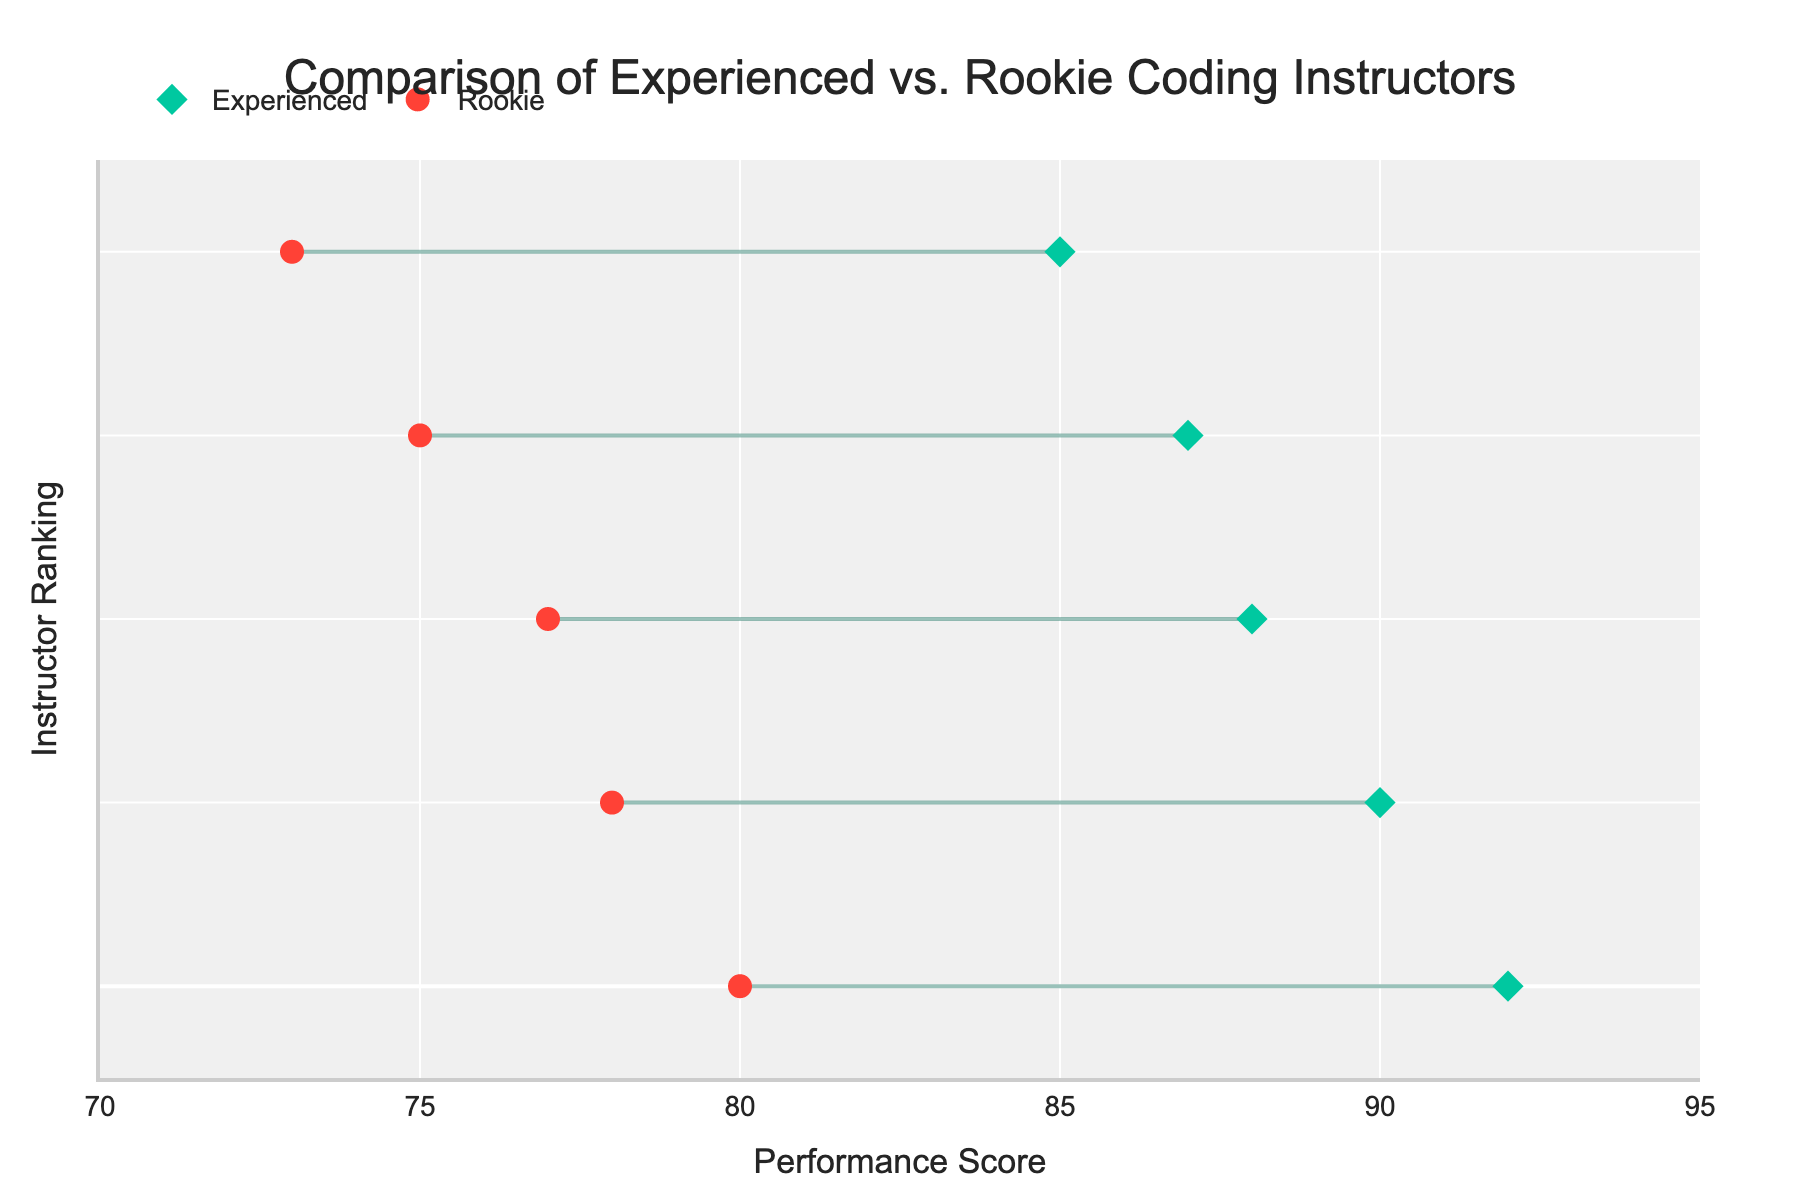What is the title of the plot? The title of the plot is located at the top center of the figure. It provides a summary of what the plot is about. By looking at the rendered figure's title area, you can read the title directly.
Answer: Comparison of Experienced vs. Rookie Coding Instructors What is the performance score of the highest-scoring experienced instructor? The plot ranks experienced instructors and rookie instructors separately on the y-axis, with performance scores on the x-axis. The highest scorer among the experienced instructors will be the point on the rightmost end of the "Experienced" markers.
Answer: 92 What is the average performance score of rookie coding instructors? To find the average, sum up the performance scores of rookie instructors and divide that by their count. The rookie scores are 75, 78, 73, 80, and 77. Summing these gives (75 + 78 + 73 + 80 + 77) = 383. Divide by the number of rookies (5), resulting in 383/5.
Answer: 76.6 Which rookie instructor has the highest performance score? Rookie instructors are represented with red markers on the chart. The highest performance score for rookie instructors will be the leftmost red marker. To identify the instructor, hover over the marker.
Answer: Daniel Wilson How many experienced instructors scored above 85? To find the number of experienced instructors scoring above 85, count the green diamond markers that are positioned to the right of the x-axis value of 85.
Answer: 4 What is the difference in performance score between the highest scoring experienced instructor and the highest scoring rookie instructor? Identify the scores for the highest scoring experienced (92) and rookie (80) instructors. Subtract the rookie score from the experienced score. Thus, 92 - 80 = 12.
Answer: 12 Compare the lowest performance scores of experienced and rookie instructors. Who has the lower score and what are the values? Identify the lowest performance score among both groups from their markers. For experienced, the lowest is 85. For rookies, the lowest is 73. Compare both values.
Answer: Rookie has the lower score. Experienced: 85, Rookie: 73 Which instructor has the largest performance score difference between experienced and rookie categories? Look at the lines connecting the performance scores of paired experienced and rookie instructors. The longest line gives the largest difference. Find the scores on either end of that line and calculate the difference.
Answer: Jane Smith and Sarah Brown (90 - 75 = 15) What color represents experienced instructors? The color for the experienced instructors is used in the markers representing them. By looking at these markers, the color can be identified.
Answer: Green What is the average performance score of experienced coding instructors? Sum the performance scores of experienced instructors and divide by their count. The scores are 85, 90, 88, 92, and 87. Sum: 85+90+88+92+87 = 442. Divide by number of experienced instructors (5), resulting in 442/5.
Answer: 88.4 